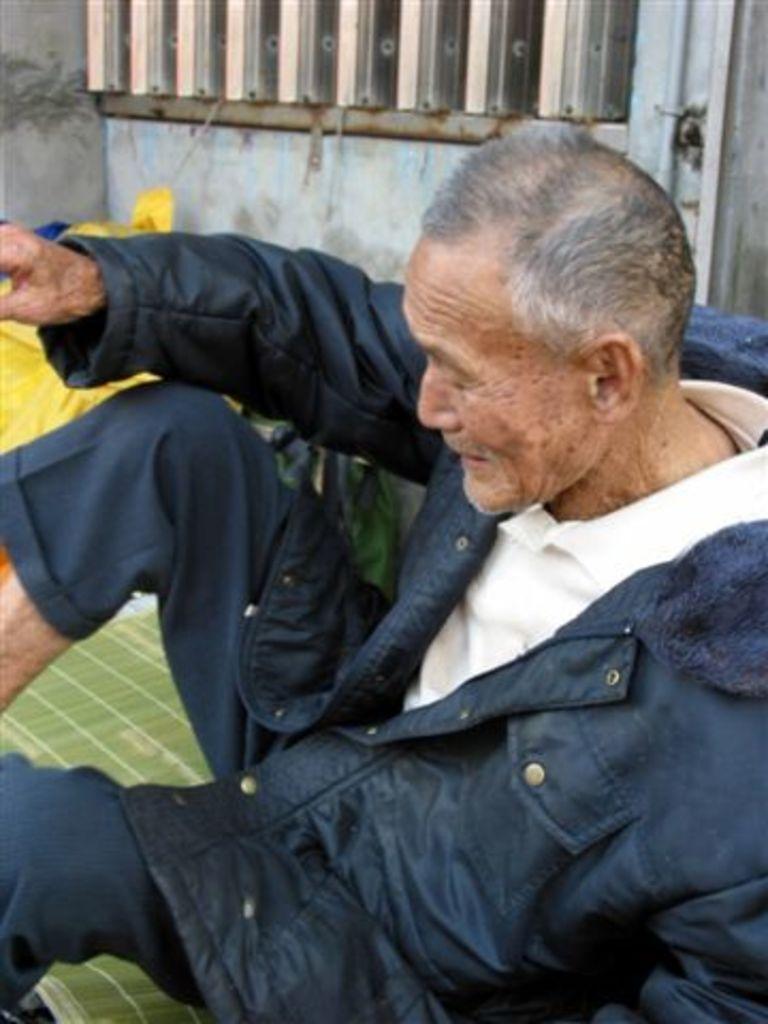What is the person in the image doing? The person is sitting on the floor in the image. What can be seen in the background of the image? There is a building beside the person in the image. What type of channel can be seen running through the dirt in the image? There is no channel or dirt present in the image; it features a person sitting on the floor and a building in the background. 